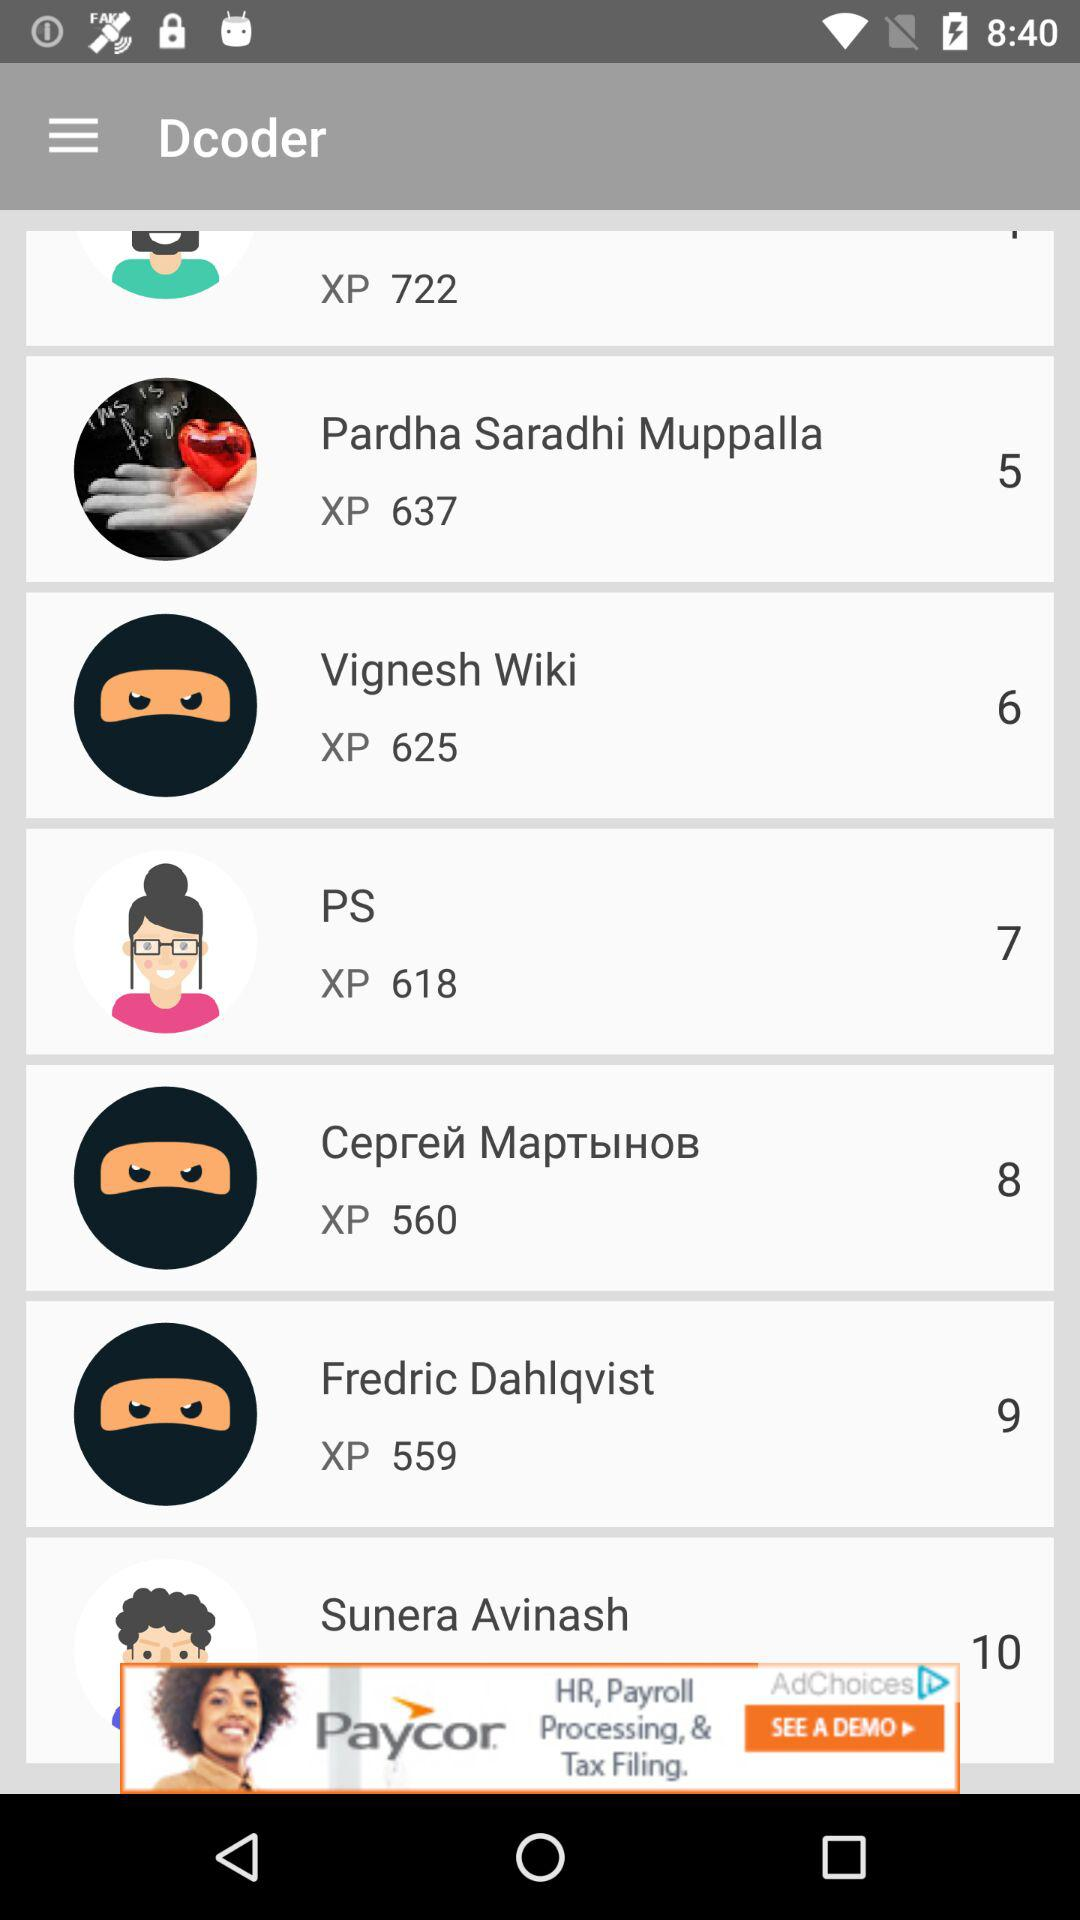What is the name of xp 560?
When the provided information is insufficient, respond with <no answer>. <no answer> 